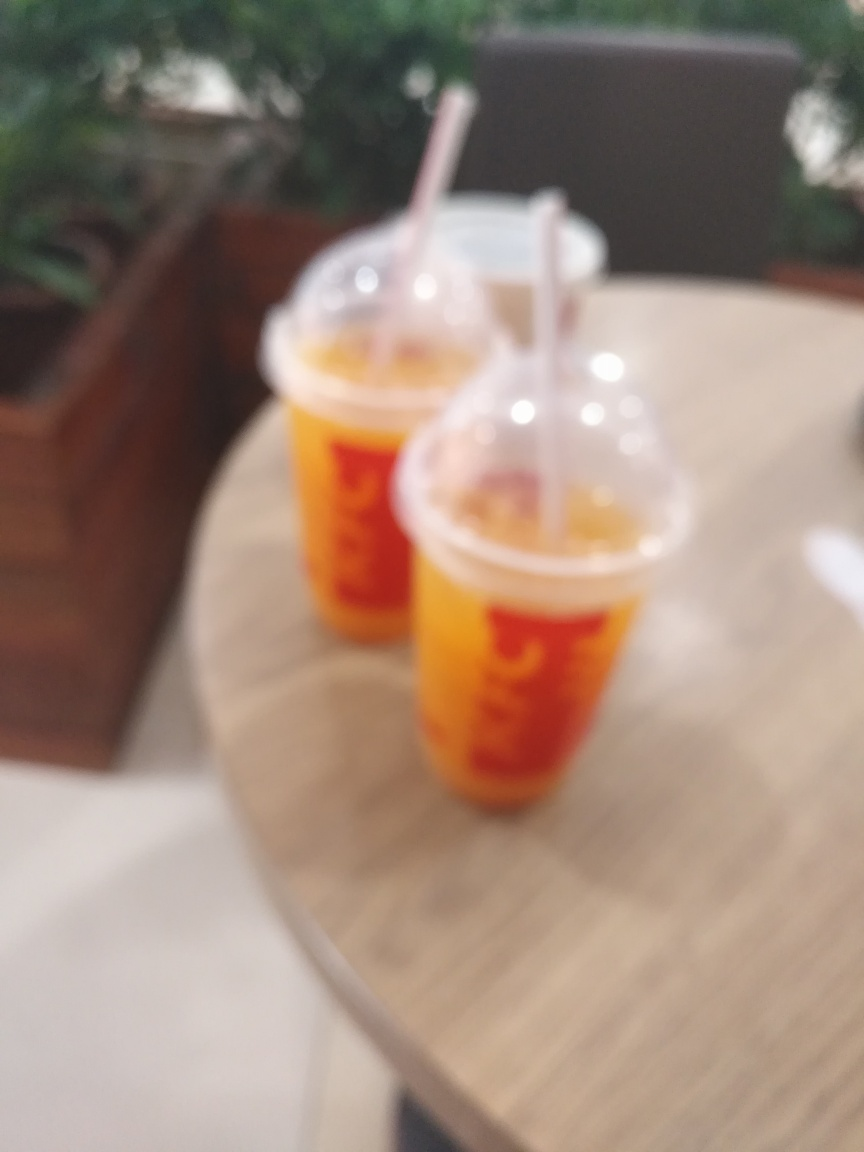Judging by the appearance, what would you say is contained in the two cups? Although the blur obscures finer details, the vividness of the orange color visible through the cups suggests a liquid content, potentially a cold beverage such as orange juice, a fruit smoothie, or a flavored iced tea. The presence of straws also indicates that these are drinks meant to be consumed cold. 